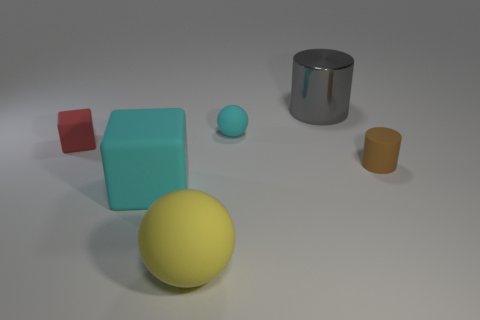Is the size of the matte sphere that is behind the big yellow sphere the same as the gray metal object that is behind the large yellow matte object? The matte sphere behind the large yellow sphere is slightly smaller in size when compared to the gray metal cylinder behind the large yellow cube. The objects are similar in height but differ in volume due to their shapes. 